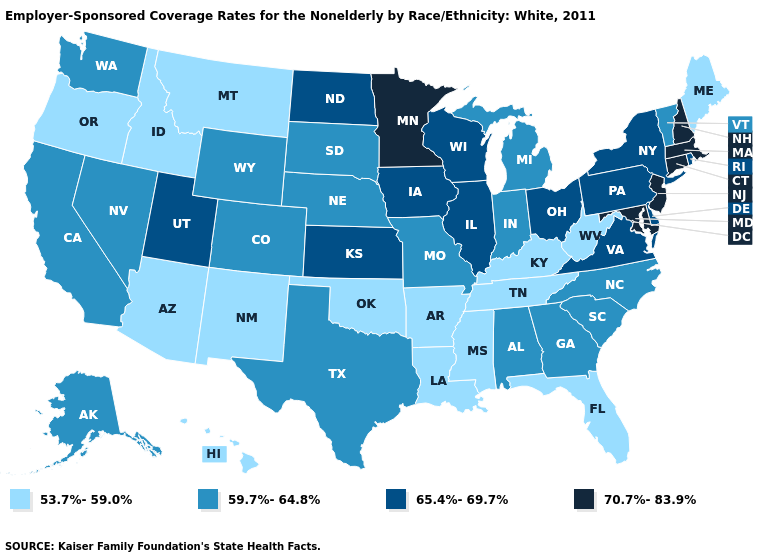Does Missouri have the lowest value in the MidWest?
Answer briefly. Yes. Name the states that have a value in the range 59.7%-64.8%?
Short answer required. Alabama, Alaska, California, Colorado, Georgia, Indiana, Michigan, Missouri, Nebraska, Nevada, North Carolina, South Carolina, South Dakota, Texas, Vermont, Washington, Wyoming. Among the states that border Arizona , does Utah have the highest value?
Concise answer only. Yes. What is the lowest value in states that border Minnesota?
Give a very brief answer. 59.7%-64.8%. What is the highest value in states that border Louisiana?
Be succinct. 59.7%-64.8%. Does New York have the highest value in the USA?
Quick response, please. No. Does the map have missing data?
Quick response, please. No. What is the value of Utah?
Short answer required. 65.4%-69.7%. Does Florida have the lowest value in the USA?
Concise answer only. Yes. What is the value of South Dakota?
Short answer required. 59.7%-64.8%. What is the value of Hawaii?
Be succinct. 53.7%-59.0%. What is the lowest value in the USA?
Concise answer only. 53.7%-59.0%. Does Tennessee have the highest value in the South?
Short answer required. No. Among the states that border Alabama , does Georgia have the lowest value?
Give a very brief answer. No. 